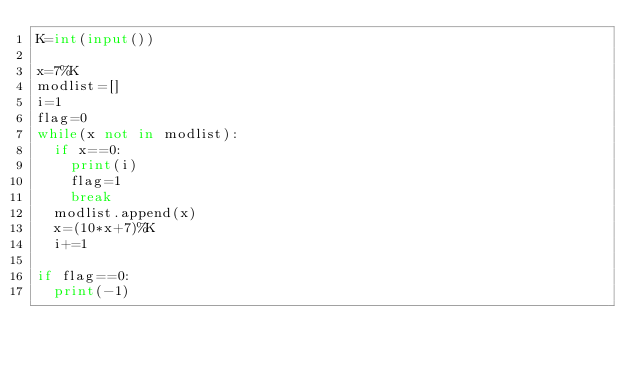<code> <loc_0><loc_0><loc_500><loc_500><_Python_>K=int(input())

x=7%K
modlist=[]
i=1
flag=0
while(x not in modlist):
  if x==0:
    print(i)
    flag=1
    break
  modlist.append(x)
  x=(10*x+7)%K
  i+=1

if flag==0:
  print(-1)</code> 